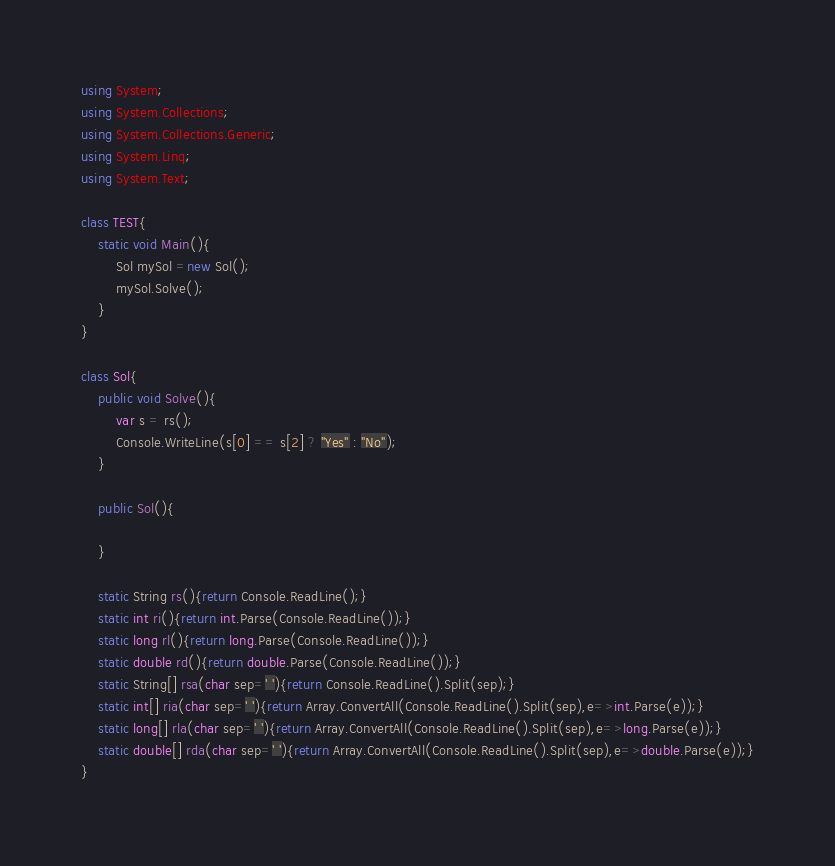<code> <loc_0><loc_0><loc_500><loc_500><_C#_>using System;
using System.Collections;
using System.Collections.Generic;
using System.Linq;
using System.Text;

class TEST{
	static void Main(){
		Sol mySol =new Sol();
		mySol.Solve();
	}
}

class Sol{
	public void Solve(){
		var s = rs();
		Console.WriteLine(s[0] == s[2] ? "Yes" : "No");
	}

	public Sol(){
		
	}

	static String rs(){return Console.ReadLine();}
	static int ri(){return int.Parse(Console.ReadLine());}
	static long rl(){return long.Parse(Console.ReadLine());}
	static double rd(){return double.Parse(Console.ReadLine());}
	static String[] rsa(char sep=' '){return Console.ReadLine().Split(sep);}
	static int[] ria(char sep=' '){return Array.ConvertAll(Console.ReadLine().Split(sep),e=>int.Parse(e));}
	static long[] rla(char sep=' '){return Array.ConvertAll(Console.ReadLine().Split(sep),e=>long.Parse(e));}
	static double[] rda(char sep=' '){return Array.ConvertAll(Console.ReadLine().Split(sep),e=>double.Parse(e));}
}
</code> 